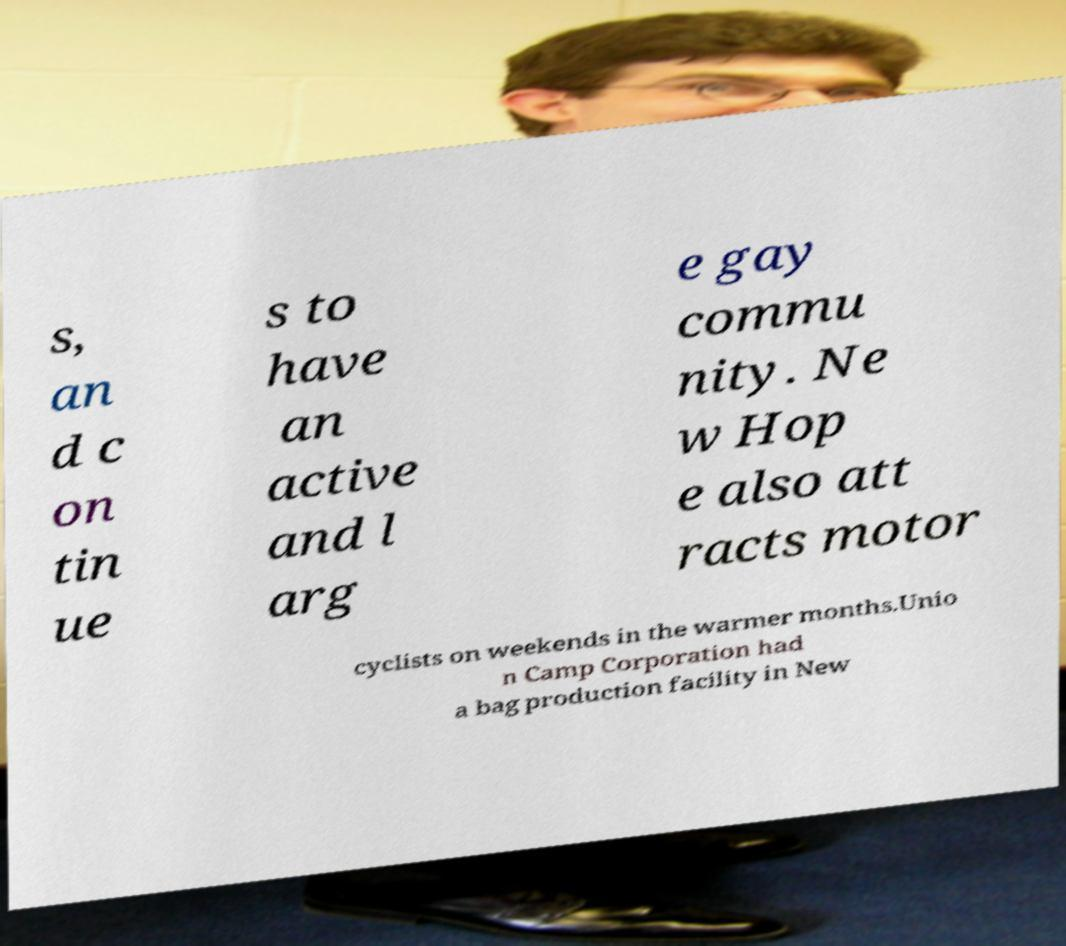Can you accurately transcribe the text from the provided image for me? s, an d c on tin ue s to have an active and l arg e gay commu nity. Ne w Hop e also att racts motor cyclists on weekends in the warmer months.Unio n Camp Corporation had a bag production facility in New 